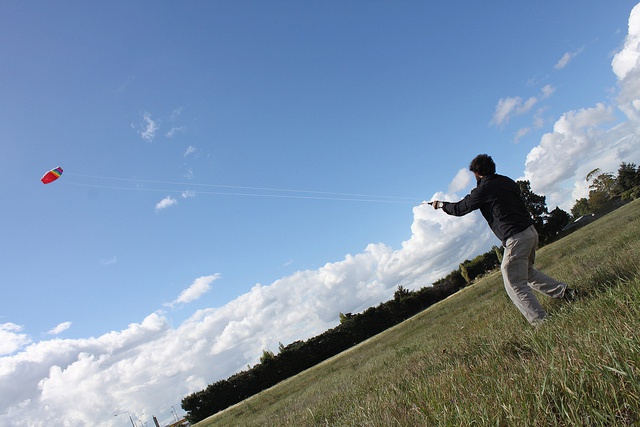Describe the objects in this image and their specific colors. I can see people in gray, black, darkgray, and darkgreen tones and kite in gray, brown, and lavender tones in this image. 